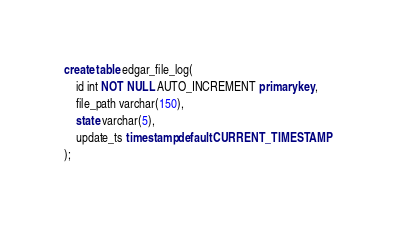Convert code to text. <code><loc_0><loc_0><loc_500><loc_500><_SQL_>create table edgar_file_log(
    id int NOT NULL AUTO_INCREMENT primary key,
    file_path varchar(150),
    state varchar(5),
    update_ts timestamp default CURRENT_TIMESTAMP
);</code> 